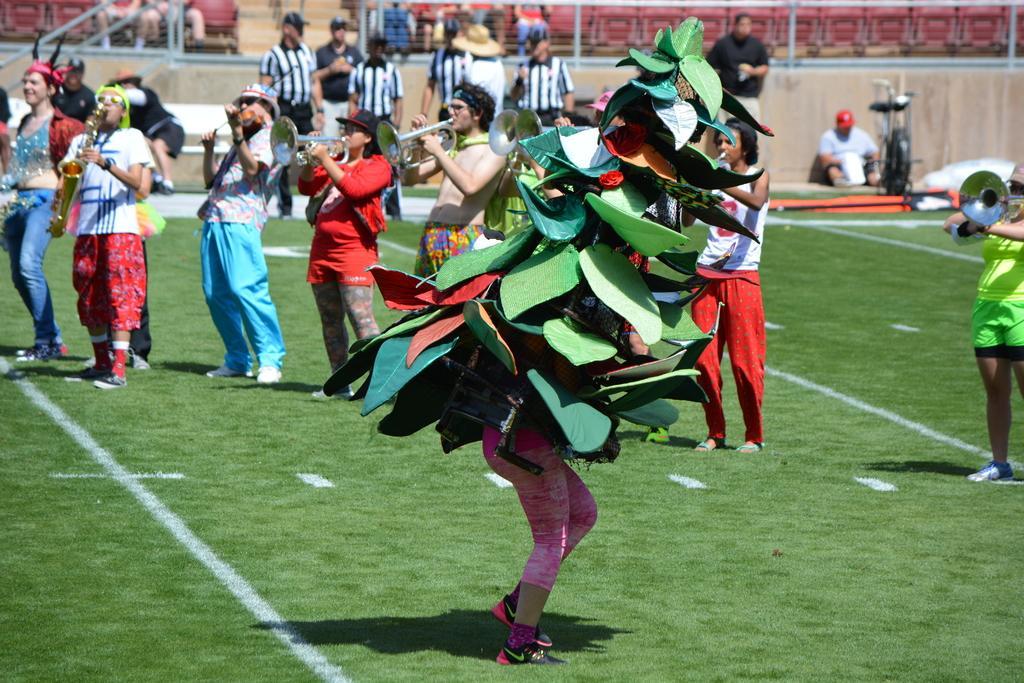How would you summarize this image in a sentence or two? In the center of the image we can see people standing and holding musical instruments. At the bottom there is a person holding an art. In the background there are seats and we can see people sitting in the seats and some of them are standing. There is a mesh. 